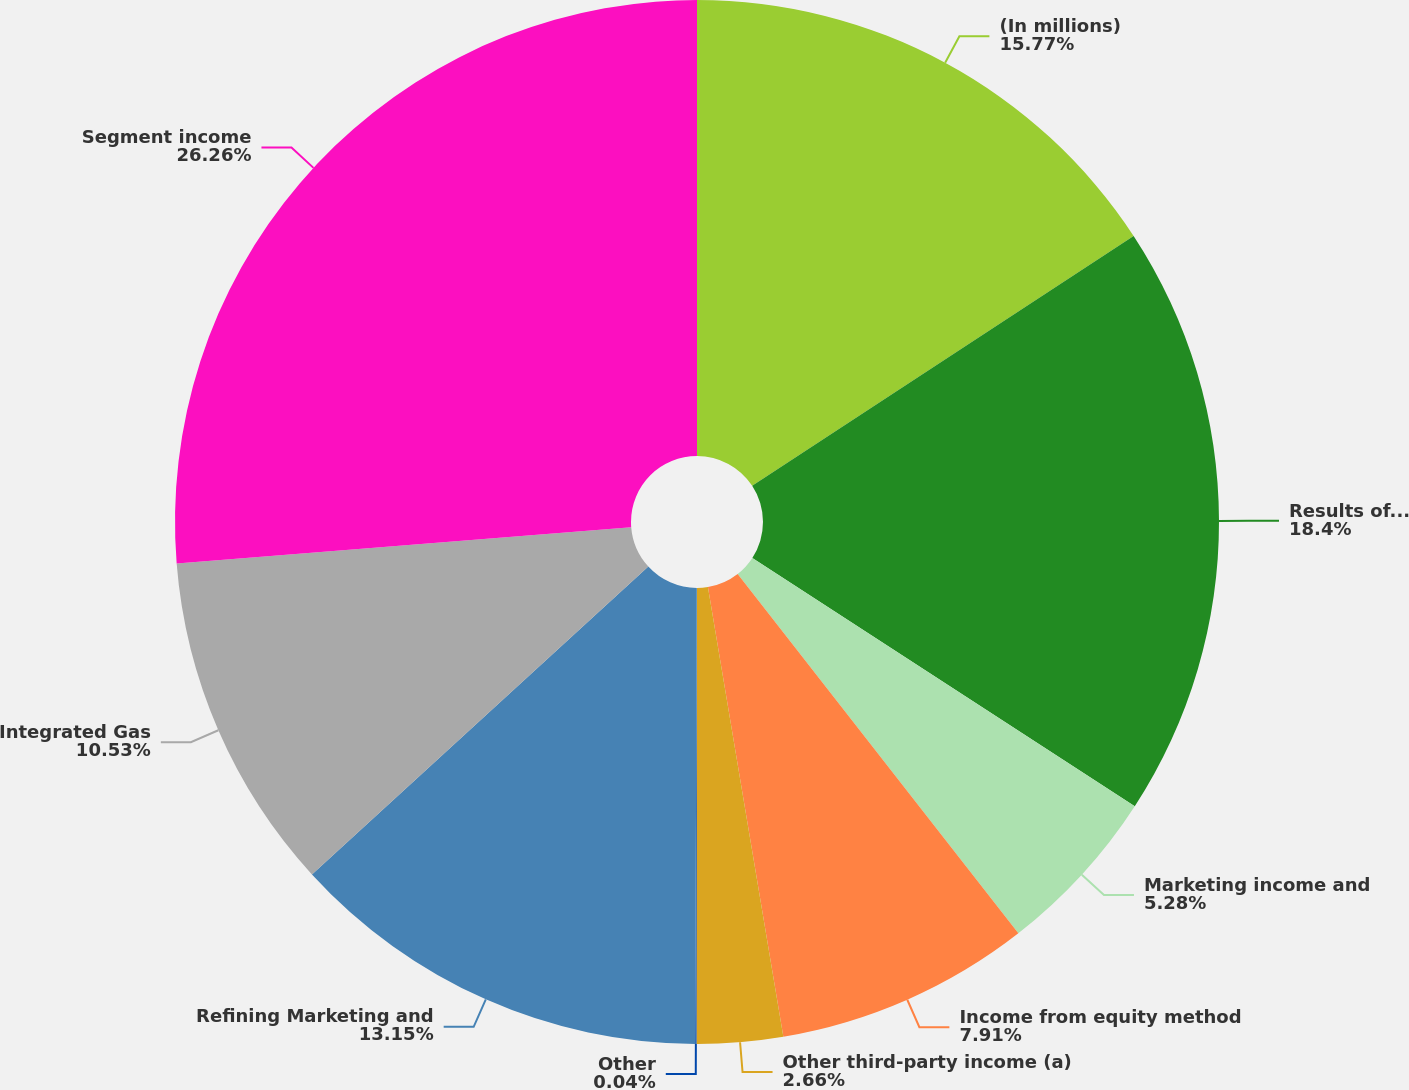Convert chart to OTSL. <chart><loc_0><loc_0><loc_500><loc_500><pie_chart><fcel>(In millions)<fcel>Results of continuing<fcel>Marketing income and<fcel>Income from equity method<fcel>Other third-party income (a)<fcel>Other<fcel>Refining Marketing and<fcel>Integrated Gas<fcel>Segment income<nl><fcel>15.77%<fcel>18.4%<fcel>5.28%<fcel>7.91%<fcel>2.66%<fcel>0.04%<fcel>13.15%<fcel>10.53%<fcel>26.27%<nl></chart> 